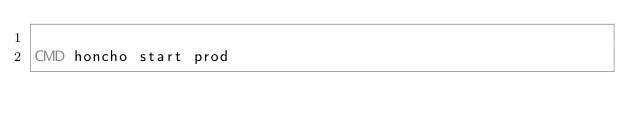Convert code to text. <code><loc_0><loc_0><loc_500><loc_500><_Dockerfile_>
CMD honcho start prod
</code> 